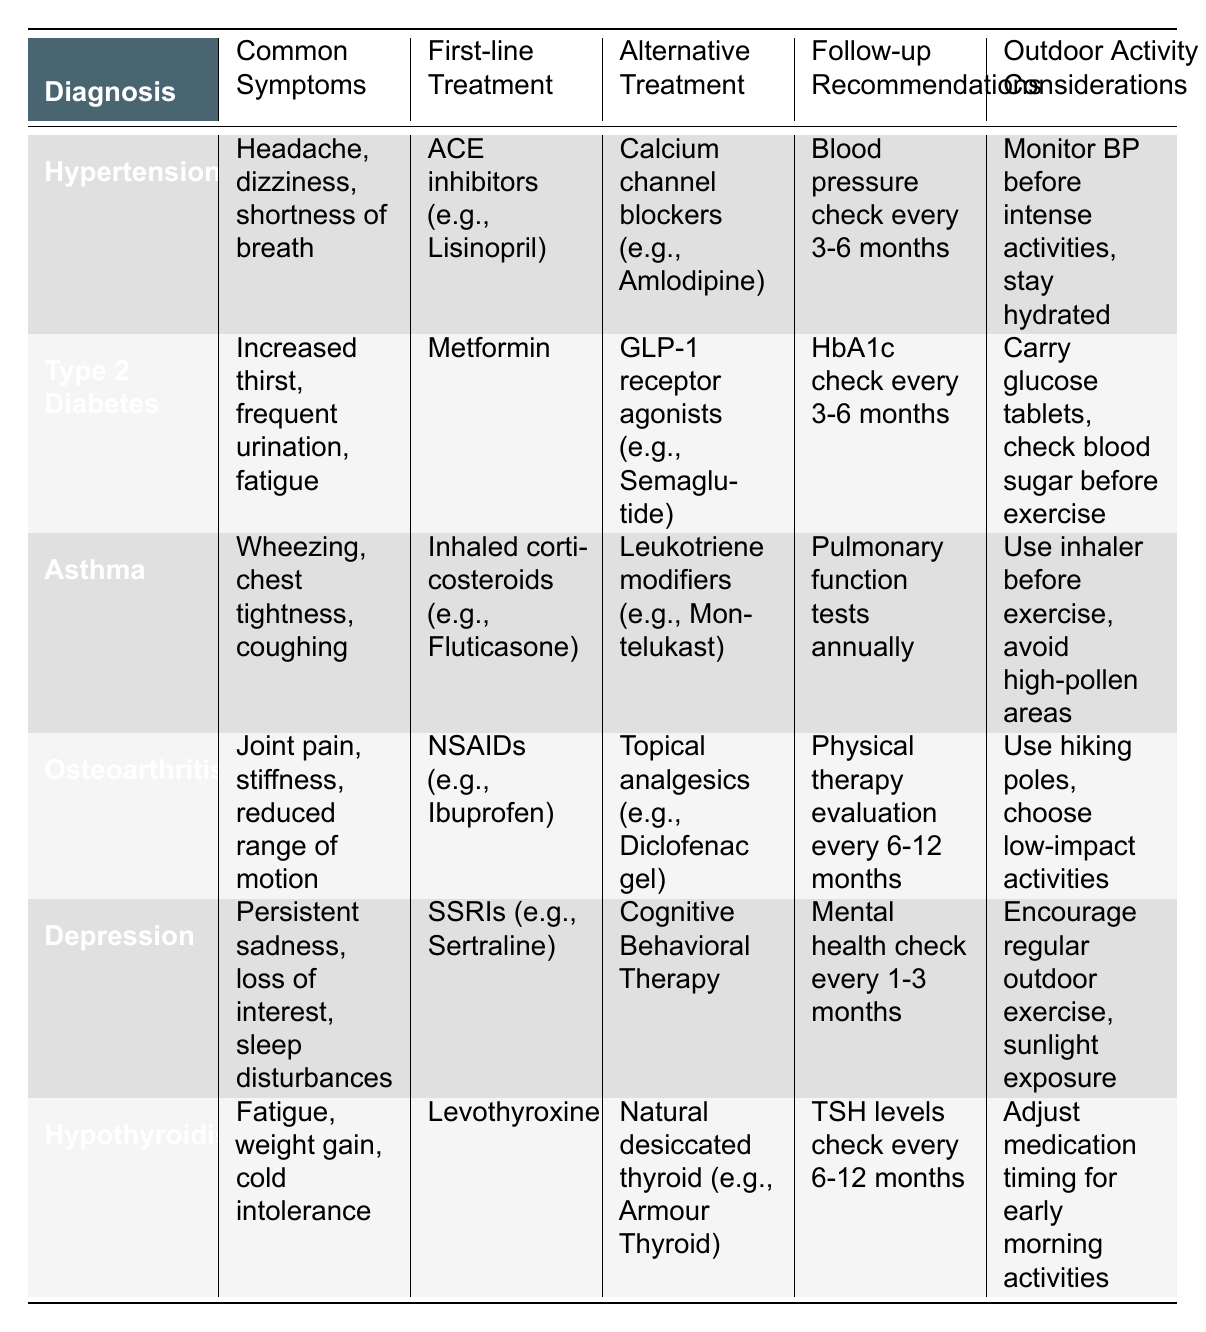What is the first-line treatment for Type 2 Diabetes? The table lists "Metformin" under the "First-line Treatment" column for Type 2 Diabetes.
Answer: Metformin Do patients with Asthma need pulmonary function tests? Yes, the table states "Pulmonary function tests annually" under the follow-up recommendations for Asthma.
Answer: Yes Which diagnosis has a first-line treatment of Levothyroxine? The table shows that "Hypothyroidism" is the diagnosis with "Levothyroxine" listed as the first-line treatment.
Answer: Hypothyroidism What are the common symptoms of Osteoarthritis? The table lists "Joint pain, stiffness, reduced range of motion" as the common symptoms for Osteoarthritis.
Answer: Joint pain, stiffness, reduced range of motion Which treatment options are available for Depression? The first-line treatment is "SSRIs (e.g., Sertraline)" and the alternative treatment is "Cognitive Behavioral Therapy".
Answer: SSRIs (e.g., Sertraline) and Cognitive Behavioral Therapy What is the follow-up recommendation for patients with Hypertension? The table indicates that patients with hypertension should have a blood pressure check every 3-6 months.
Answer: Blood pressure check every 3-6 months If a person with Type 2 Diabetes is planning to exercise outdoors, what should they carry? The table mentions that they should "Carry glucose tablets" under outdoor activity considerations for Type 2 Diabetes.
Answer: Glucose tablets Which diagnosis involves the symptom of fatigue? The diagnoses listed that include fatigue are "Type 2 Diabetes" and "Hypothyroidism".
Answer: Type 2 Diabetes and Hypothyroidism What is the difference in first-line treatments for Hypertension and Depression? Hypertension's first-line treatment is "ACE inhibitors (e.g., Lisinopril)" while Depression's first-line treatment is "SSRIs (e.g., Sertraline)"; the difference is in the medication classes used.
Answer: ACE inhibitors and SSRIs 